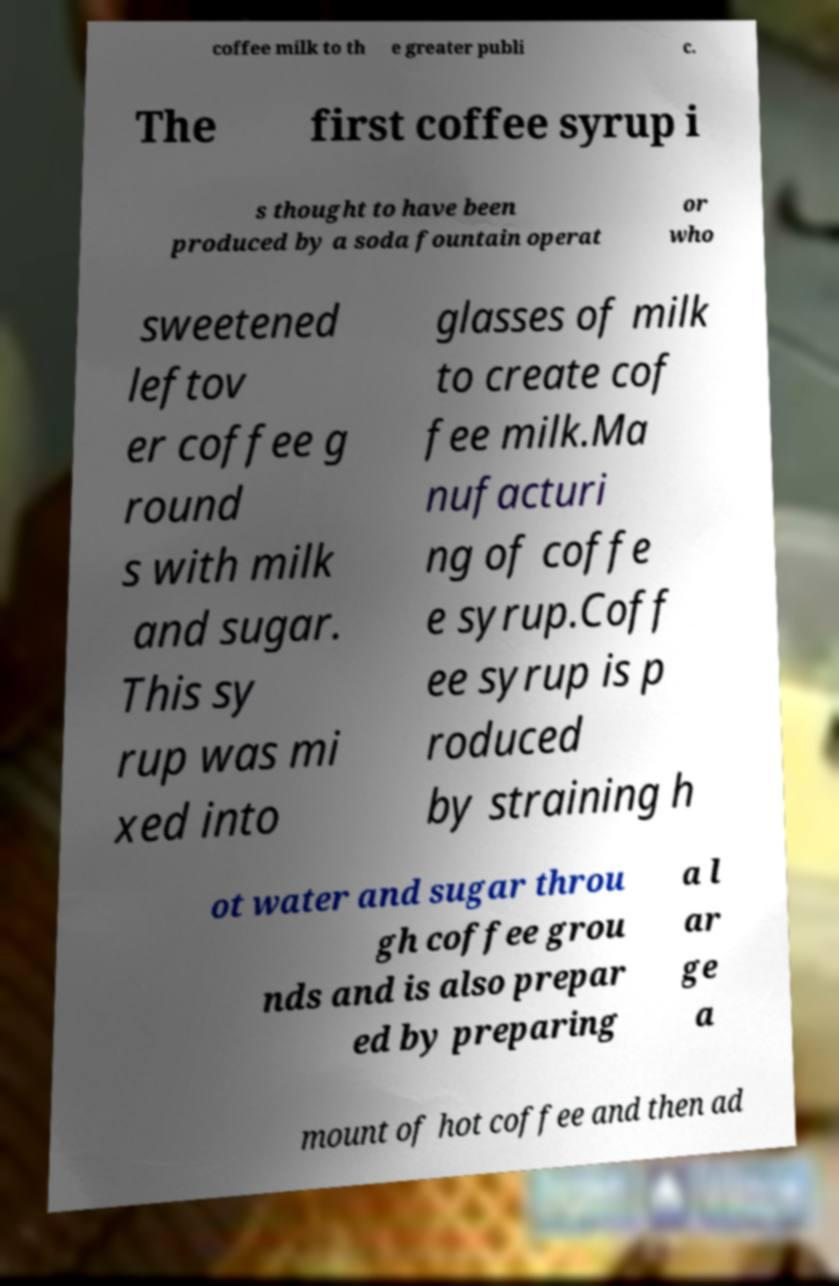Can you accurately transcribe the text from the provided image for me? coffee milk to th e greater publi c. The first coffee syrup i s thought to have been produced by a soda fountain operat or who sweetened leftov er coffee g round s with milk and sugar. This sy rup was mi xed into glasses of milk to create cof fee milk.Ma nufacturi ng of coffe e syrup.Coff ee syrup is p roduced by straining h ot water and sugar throu gh coffee grou nds and is also prepar ed by preparing a l ar ge a mount of hot coffee and then ad 